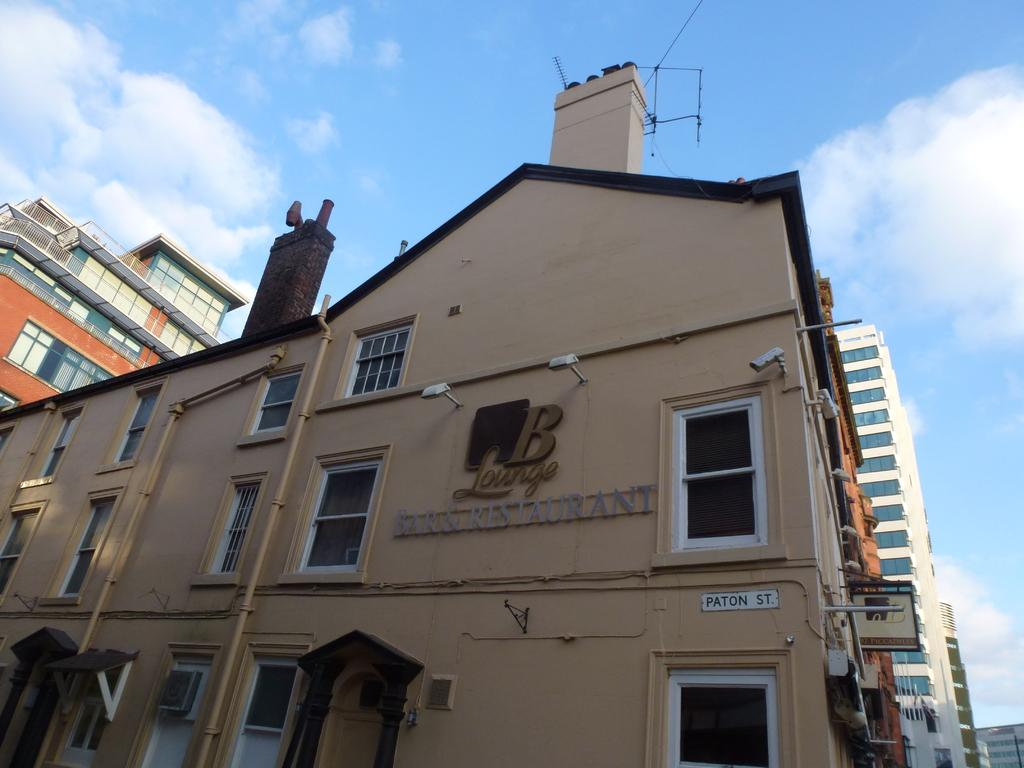What type of structures can be seen in the image? There are buildings in the image. How would you describe the sky in the image? The sky is cloudy in the image. Are there any additional details on the buildings in the image? Yes, there are texts written on a building in the image. What type of plastic is used to make the drawer in the image? There is no drawer present in the image, so it is not possible to determine the type of plastic used. 